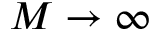Convert formula to latex. <formula><loc_0><loc_0><loc_500><loc_500>M \to \infty</formula> 